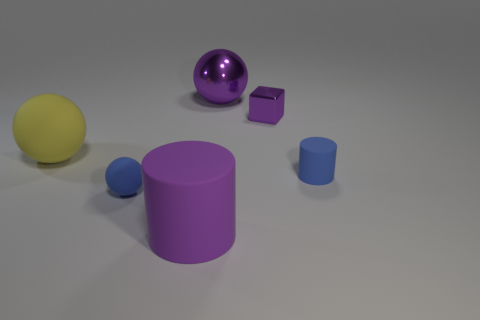Subtract 1 balls. How many balls are left? 2 Add 3 purple matte cylinders. How many objects exist? 9 Subtract all cylinders. How many objects are left? 4 Add 1 purple matte things. How many purple matte things are left? 2 Add 5 large brown metal things. How many large brown metal things exist? 5 Subtract 0 red spheres. How many objects are left? 6 Subtract all green things. Subtract all blocks. How many objects are left? 5 